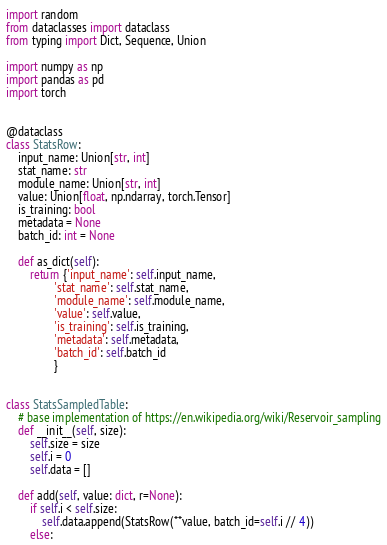<code> <loc_0><loc_0><loc_500><loc_500><_Python_>import random
from dataclasses import dataclass
from typing import Dict, Sequence, Union

import numpy as np
import pandas as pd
import torch


@dataclass
class StatsRow:
    input_name: Union[str, int]
    stat_name: str
    module_name: Union[str, int]
    value: Union[float, np.ndarray, torch.Tensor]
    is_training: bool
    metadata = None
    batch_id: int = None

    def as_dict(self):
        return {'input_name': self.input_name,
                'stat_name': self.stat_name,
                'module_name': self.module_name,
                'value': self.value,
                'is_training': self.is_training,
                'metadata': self.metadata,
                'batch_id': self.batch_id
                }


class StatsSampledTable:
    # base implementation of https://en.wikipedia.org/wiki/Reservoir_sampling
    def __init__(self, size):
        self.size = size
        self.i = 0
        self.data = []

    def add(self, value: dict, r=None):
        if self.i < self.size:
            self.data.append(StatsRow(**value, batch_id=self.i // 4))
        else:</code> 